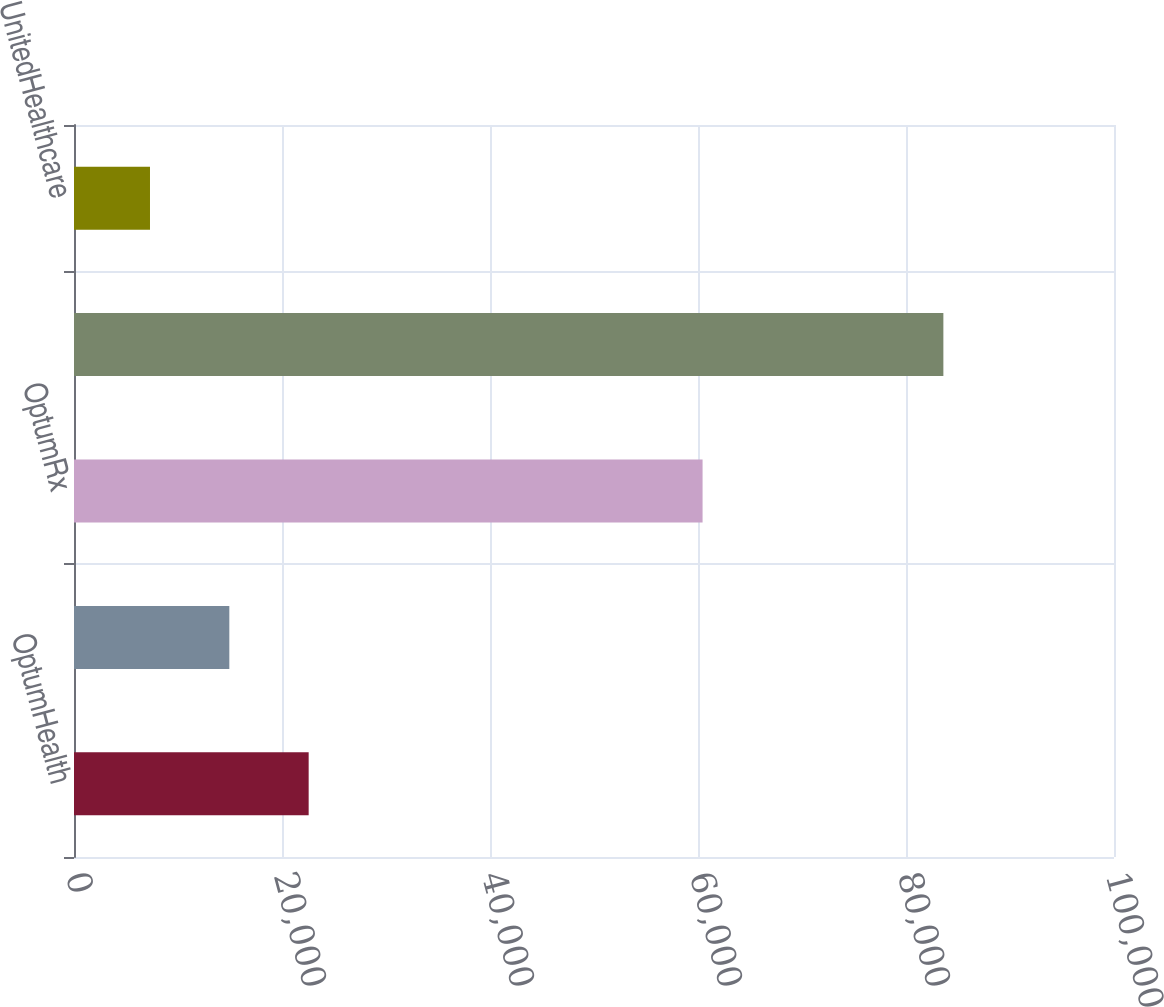<chart> <loc_0><loc_0><loc_500><loc_500><bar_chart><fcel>OptumHealth<fcel>OptumInsight<fcel>OptumRx<fcel>Optum<fcel>UnitedHealthcare<nl><fcel>22564.2<fcel>14935.6<fcel>60440<fcel>83593<fcel>7307<nl></chart> 